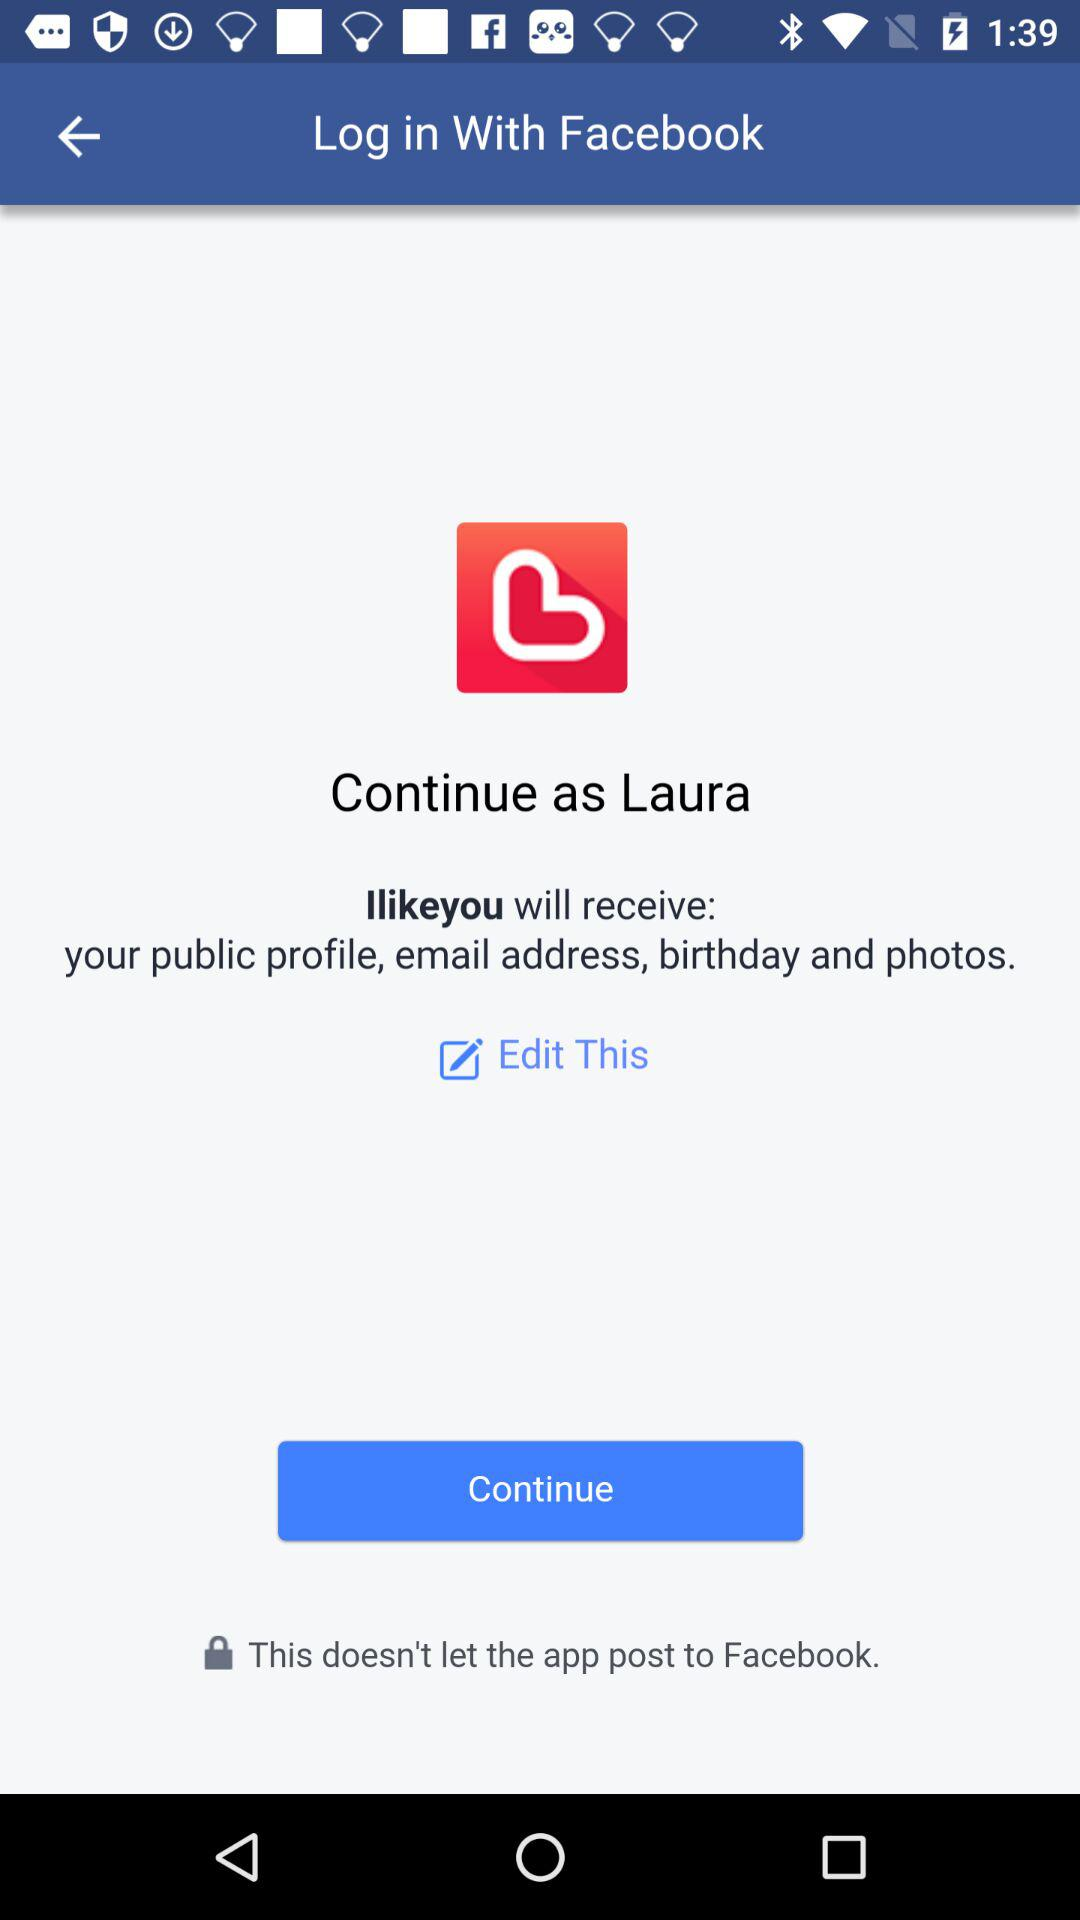What is the user's last name?
When the provided information is insufficient, respond with <no answer>. <no answer> 